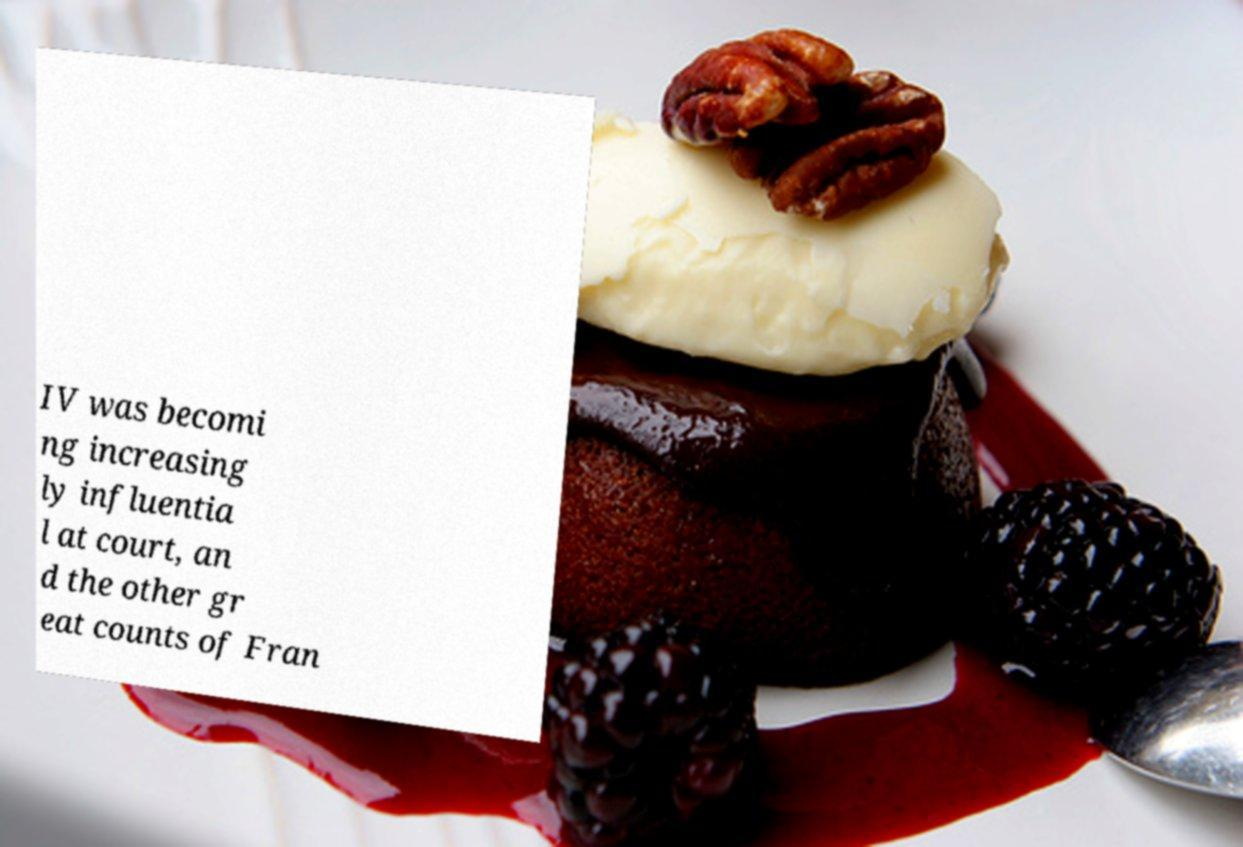There's text embedded in this image that I need extracted. Can you transcribe it verbatim? IV was becomi ng increasing ly influentia l at court, an d the other gr eat counts of Fran 